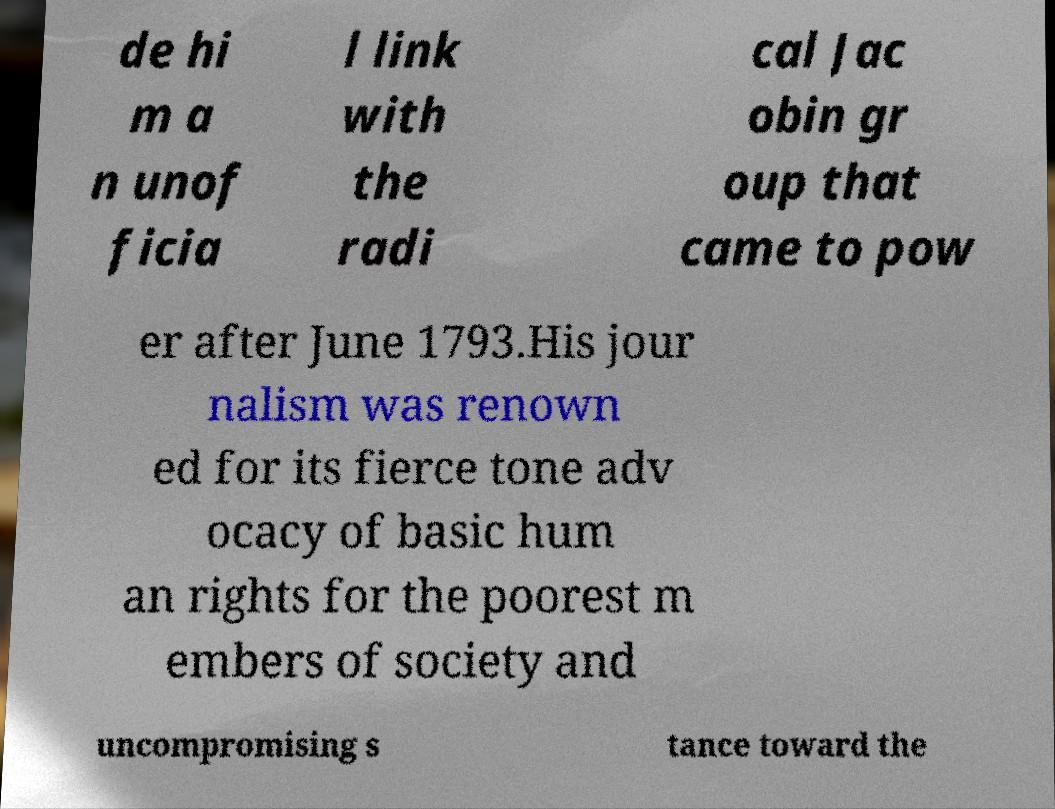Please identify and transcribe the text found in this image. de hi m a n unof ficia l link with the radi cal Jac obin gr oup that came to pow er after June 1793.His jour nalism was renown ed for its fierce tone adv ocacy of basic hum an rights for the poorest m embers of society and uncompromising s tance toward the 